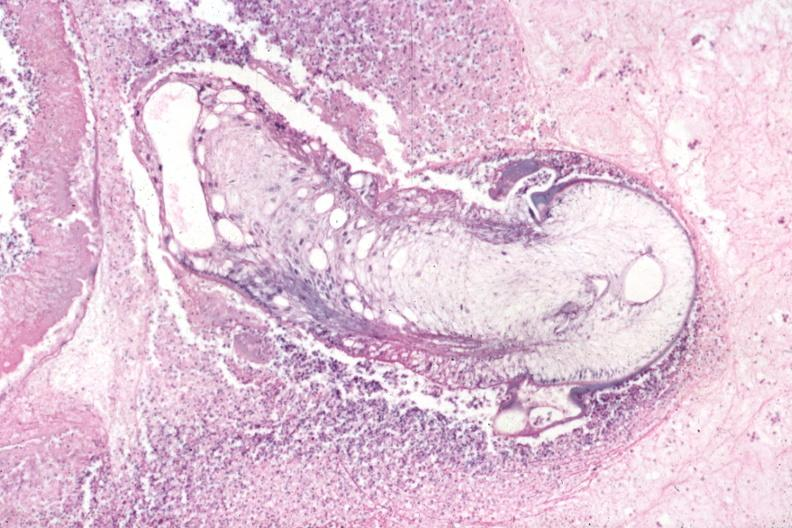what is present?
Answer the question using a single word or phrase. Cysticercosis 